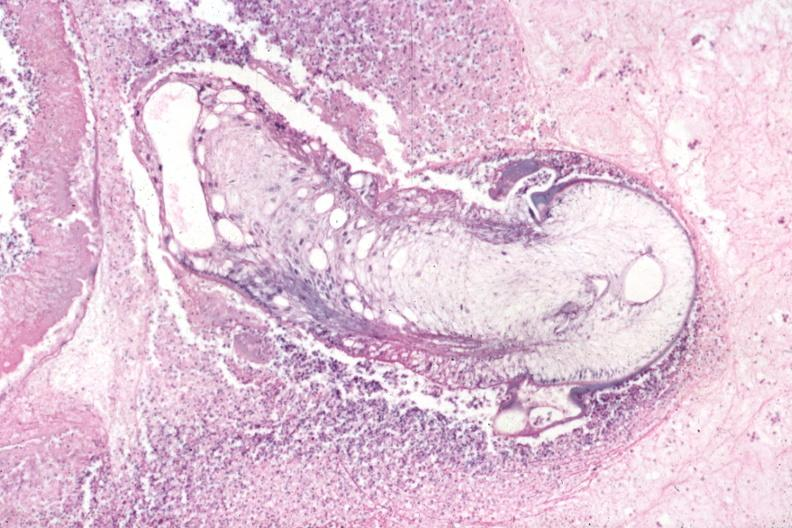what is present?
Answer the question using a single word or phrase. Cysticercosis 